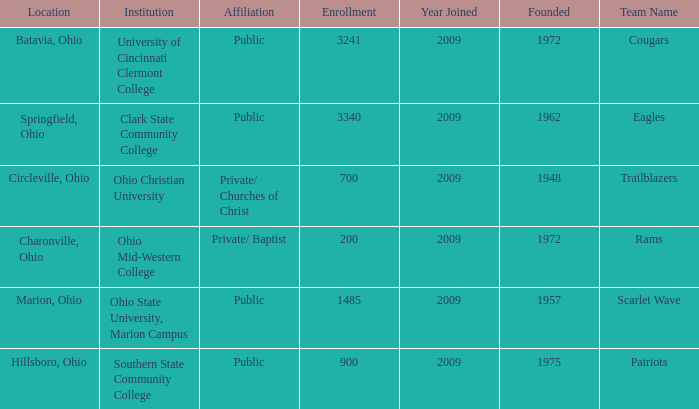How many entries are there for founded when the location was springfield, ohio? 1.0. 